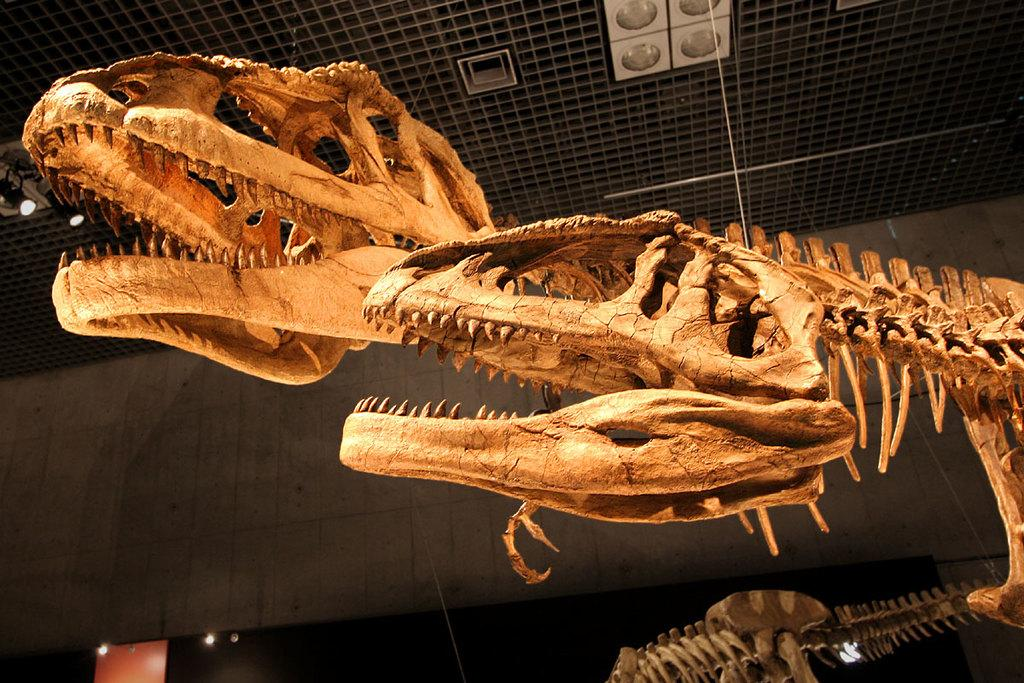What type of remains can be seen in the image? There are skeleton bones of an animal in the image. What type of structure is visible in the image? There is a wall and a roof visible in the image. What type of lighting is present in the image? There are ceiling lights in the image. What type of goat is resting on vacation in the image? There is no goat present in the image, nor is there any indication of a vacation or resting. 